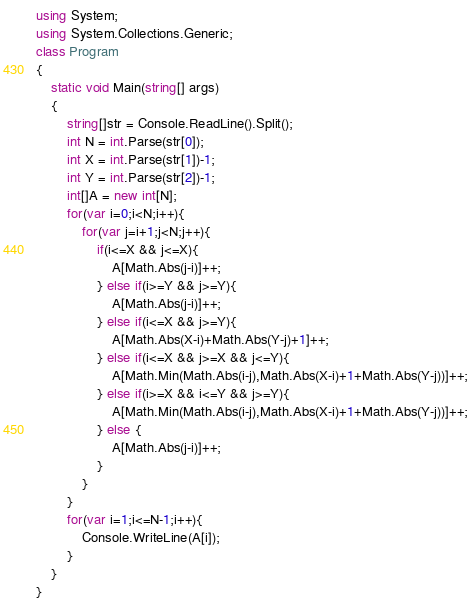<code> <loc_0><loc_0><loc_500><loc_500><_C#_>using System;
using System.Collections.Generic;
class Program
{
	static void Main(string[] args)
	{
		string[]str = Console.ReadLine().Split();
		int N = int.Parse(str[0]);
		int X = int.Parse(str[1])-1;
		int Y = int.Parse(str[2])-1;
		int[]A = new int[N];
		for(var i=0;i<N;i++){
			for(var j=i+1;j<N;j++){
				if(i<=X && j<=X){
					A[Math.Abs(j-i)]++;
				} else if(i>=Y && j>=Y){
					A[Math.Abs(j-i)]++;
				} else if(i<=X && j>=Y){
					A[Math.Abs(X-i)+Math.Abs(Y-j)+1]++;
				} else if(i<=X && j>=X && j<=Y){
					A[Math.Min(Math.Abs(i-j),Math.Abs(X-i)+1+Math.Abs(Y-j))]++;
				} else if(i>=X && i<=Y && j>=Y){
					A[Math.Min(Math.Abs(i-j),Math.Abs(X-i)+1+Math.Abs(Y-j))]++;
				} else {
                  	A[Math.Abs(j-i)]++;
                }
			}
		}
		for(var i=1;i<=N-1;i++){
			Console.WriteLine(A[i]);
		}
	}
}
</code> 